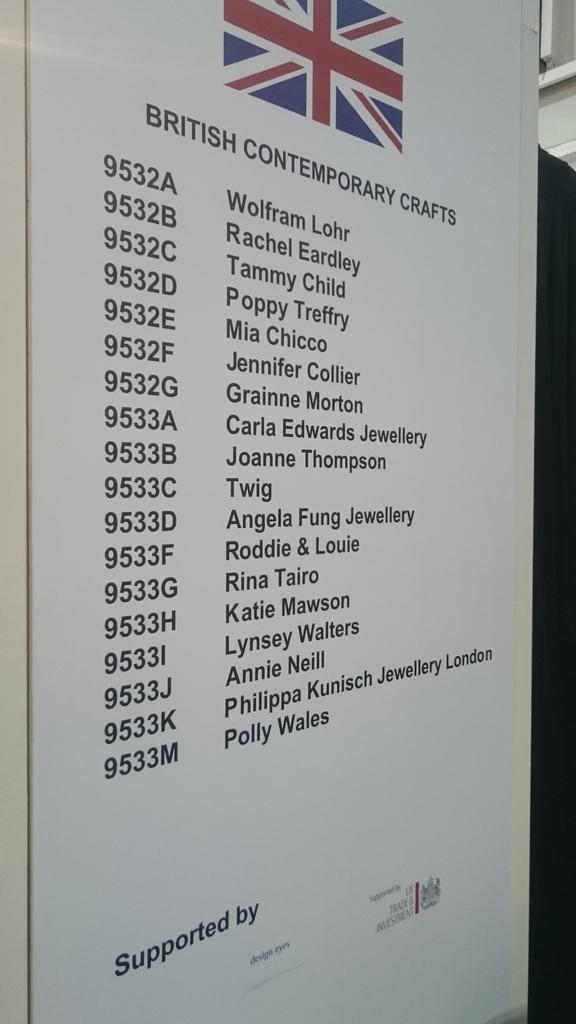Provide a one-sentence caption for the provided image. List of british contemporary crafts and names of people. 